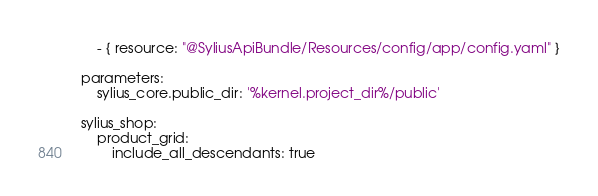<code> <loc_0><loc_0><loc_500><loc_500><_YAML_>    - { resource: "@SyliusApiBundle/Resources/config/app/config.yaml" }

parameters:
    sylius_core.public_dir: '%kernel.project_dir%/public'

sylius_shop:
    product_grid:
        include_all_descendants: true
</code> 